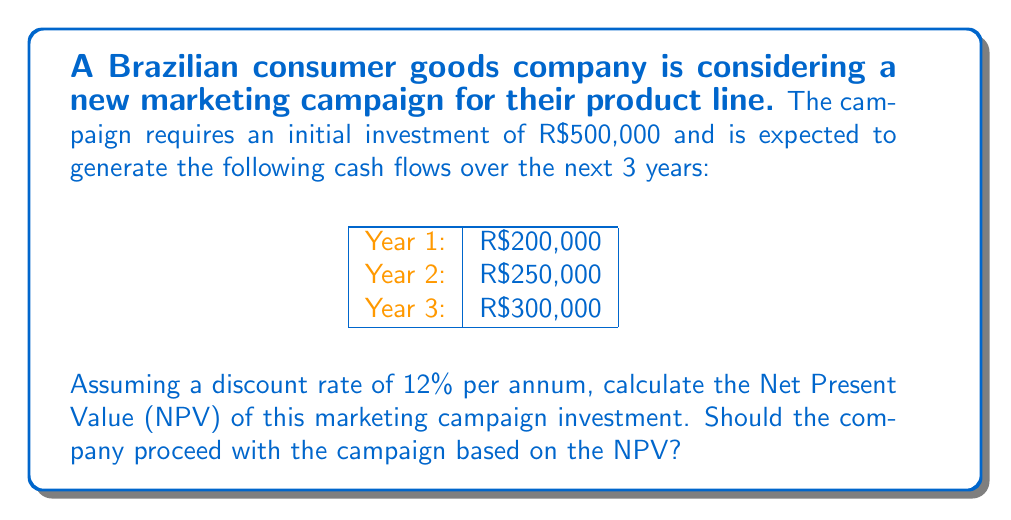Give your solution to this math problem. To calculate the Net Present Value (NPV) of the marketing campaign investment, we need to follow these steps:

1. Calculate the present value of each future cash flow
2. Sum all the present values
3. Subtract the initial investment

The formula for NPV is:

$$ NPV = -C_0 + \sum_{t=1}^{n} \frac{C_t}{(1+r)^t} $$

Where:
$C_0$ is the initial investment
$C_t$ is the cash flow at time t
$r$ is the discount rate
$n$ is the number of periods

Let's calculate the present value of each cash flow:

Year 1: $\frac{200,000}{(1+0.12)^1} = \frac{200,000}{1.12} = 178,571.43$

Year 2: $\frac{250,000}{(1+0.12)^2} = \frac{250,000}{1.2544} = 199,298.95$

Year 3: $\frac{300,000}{(1+0.12)^3} = \frac{300,000}{1.404928} = 213,532.54$

Now, let's sum all the present values and subtract the initial investment:

$$ NPV = -500,000 + 178,571.43 + 199,298.95 + 213,532.54 $$
$$ NPV = 91,402.92 $$

The NPV is positive, which means the project is expected to add value to the company. Therefore, based on the NPV, the company should proceed with the marketing campaign.
Answer: The Net Present Value (NPV) of the marketing campaign investment is R$91,402.92. Since the NPV is positive, the company should proceed with the campaign. 